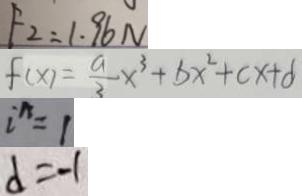Convert formula to latex. <formula><loc_0><loc_0><loc_500><loc_500>F _ { 2 } = 1 . 9 6 N 
 f ( x ) = \frac { a } { 3 } x ^ { 3 } + b x ^ { 2 } + c x + d 
 i ^ { n } = 1 
 d = - 1</formula> 